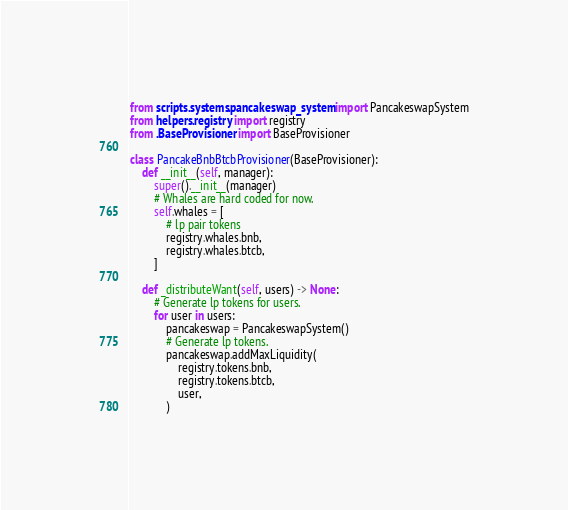Convert code to text. <code><loc_0><loc_0><loc_500><loc_500><_Python_>from scripts.systems.pancakeswap_system import PancakeswapSystem
from helpers.registry import registry
from .BaseProvisioner import BaseProvisioner

class PancakeBnbBtcbProvisioner(BaseProvisioner):
    def __init__(self, manager):
        super().__init__(manager)
        # Whales are hard coded for now.
        self.whales = [
            # lp pair tokens
            registry.whales.bnb,
            registry.whales.btcb,
        ]

    def _distributeWant(self, users) -> None:
        # Generate lp tokens for users.
        for user in users:
            pancakeswap = PancakeswapSystem()
            # Generate lp tokens.
            pancakeswap.addMaxLiquidity(
                registry.tokens.bnb,
                registry.tokens.btcb,
                user,
            )
</code> 